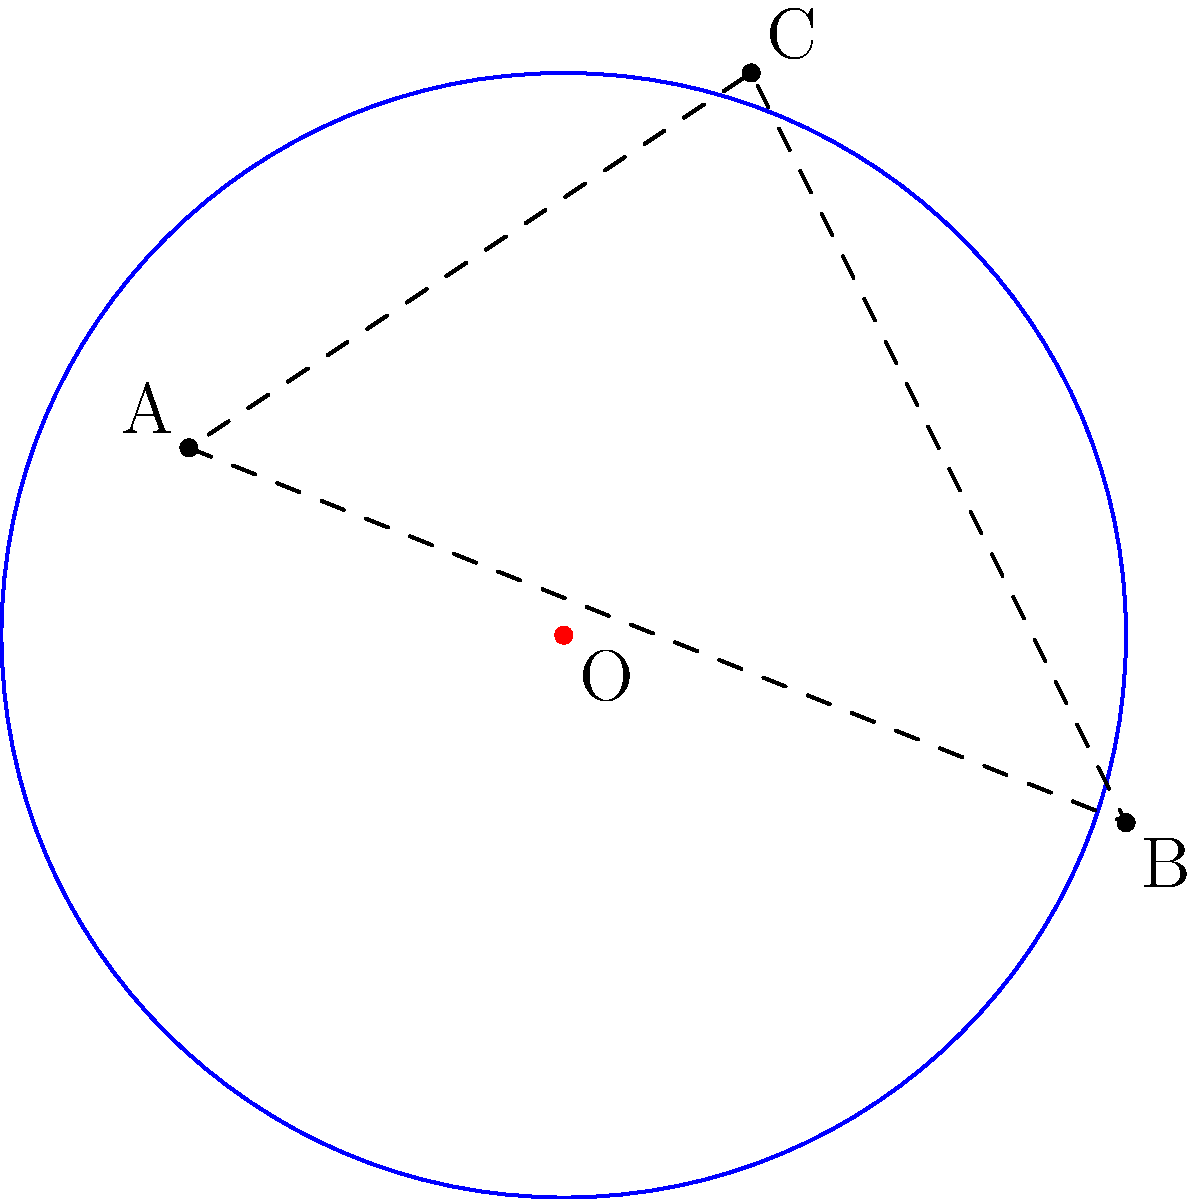In your research on an unsung historical figure, you've identified three key locations (A, B, and C) that represent the extent of their sphere of influence. To visualize this impact, you want to find the circle that encompasses these points. Given the coordinates A(-2,1), B(3,-1), and C(1,3), determine the center (h,k) and radius r of the circle that passes through these three points. To find the center and radius of the circle passing through three points, we can follow these steps:

1) Use the general equation of a circle: $(x-h)^2 + (y-k)^2 = r^2$, where (h,k) is the center and r is the radius.

2) Substitute the coordinates of each point into this equation:
   For A: $(-2-h)^2 + (1-k)^2 = r^2$
   For B: $(3-h)^2 + (-1-k)^2 = r^2$
   For C: $(1-h)^2 + (3-k)^2 = r^2$

3) Subtract equation A from B and C:
   B-A: $25 - 10h = -4 - 2k$
   C-A: $9 - 6h = 4 - 4k$

4) Simplify:
   $5h - k = \frac{29}{2}$
   $3h - 2k = \frac{5}{2}$

5) Solve this system of equations:
   Multiply the second equation by 2: $6h - 4k = 5$
   Subtract from the first equation: $4h + 3k = 24$
   
   Solve for k: $k = 8 - \frac{4h}{3}$
   
   Substitute back: $5h - (8 - \frac{4h}{3}) = \frac{29}{2}$
   Simplify: $19h = \frac{93}{2}$
   $h = \frac{93}{38} \approx 2.447$

   $k = 8 - \frac{4}{3}(\frac{93}{38}) \approx 0.974$

6) To find r, substitute (h,k) into any of the original equations:
   $r^2 = (-2-\frac{93}{38})^2 + (1-\frac{37}{38})^2 \approx 9.002$
   $r \approx 3$

Therefore, the center is approximately (2.447, 0.974) and the radius is approximately 3.
Answer: Center: $(\frac{93}{38}, \frac{37}{38})$, Radius: $3$ 